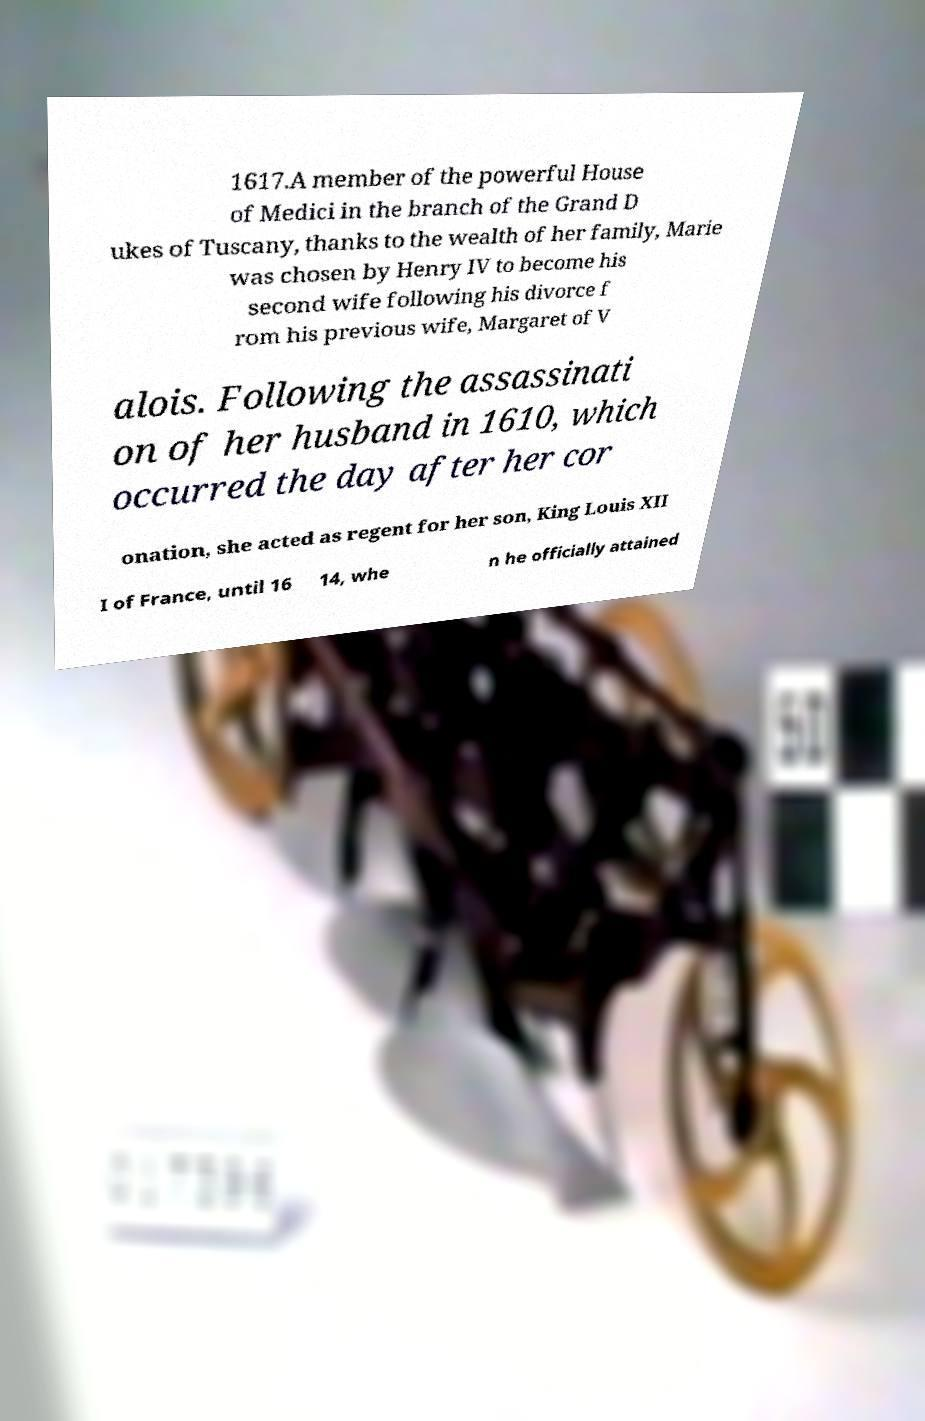Could you extract and type out the text from this image? 1617.A member of the powerful House of Medici in the branch of the Grand D ukes of Tuscany, thanks to the wealth of her family, Marie was chosen by Henry IV to become his second wife following his divorce f rom his previous wife, Margaret of V alois. Following the assassinati on of her husband in 1610, which occurred the day after her cor onation, she acted as regent for her son, King Louis XII I of France, until 16 14, whe n he officially attained 